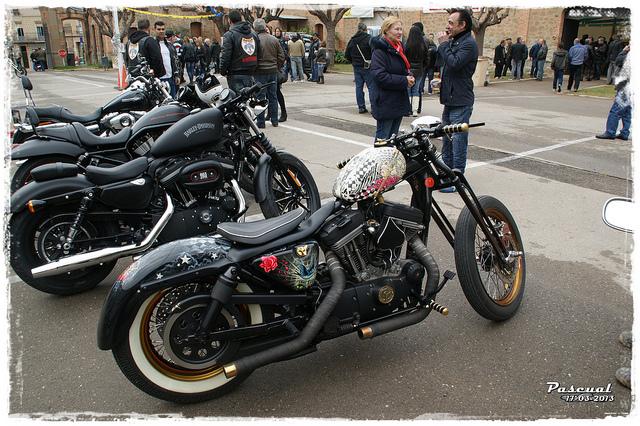What kind of vehicle is shown?
Give a very brief answer. Motorcycle. What color are the rims on the motorcycle in front?
Keep it brief. Gold. Is there more than one motorcycle in this image?
Keep it brief. Yes. 